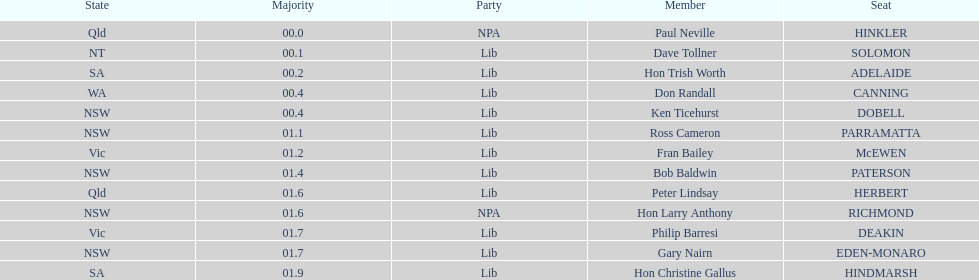What is the name of the last seat? HINDMARSH. 